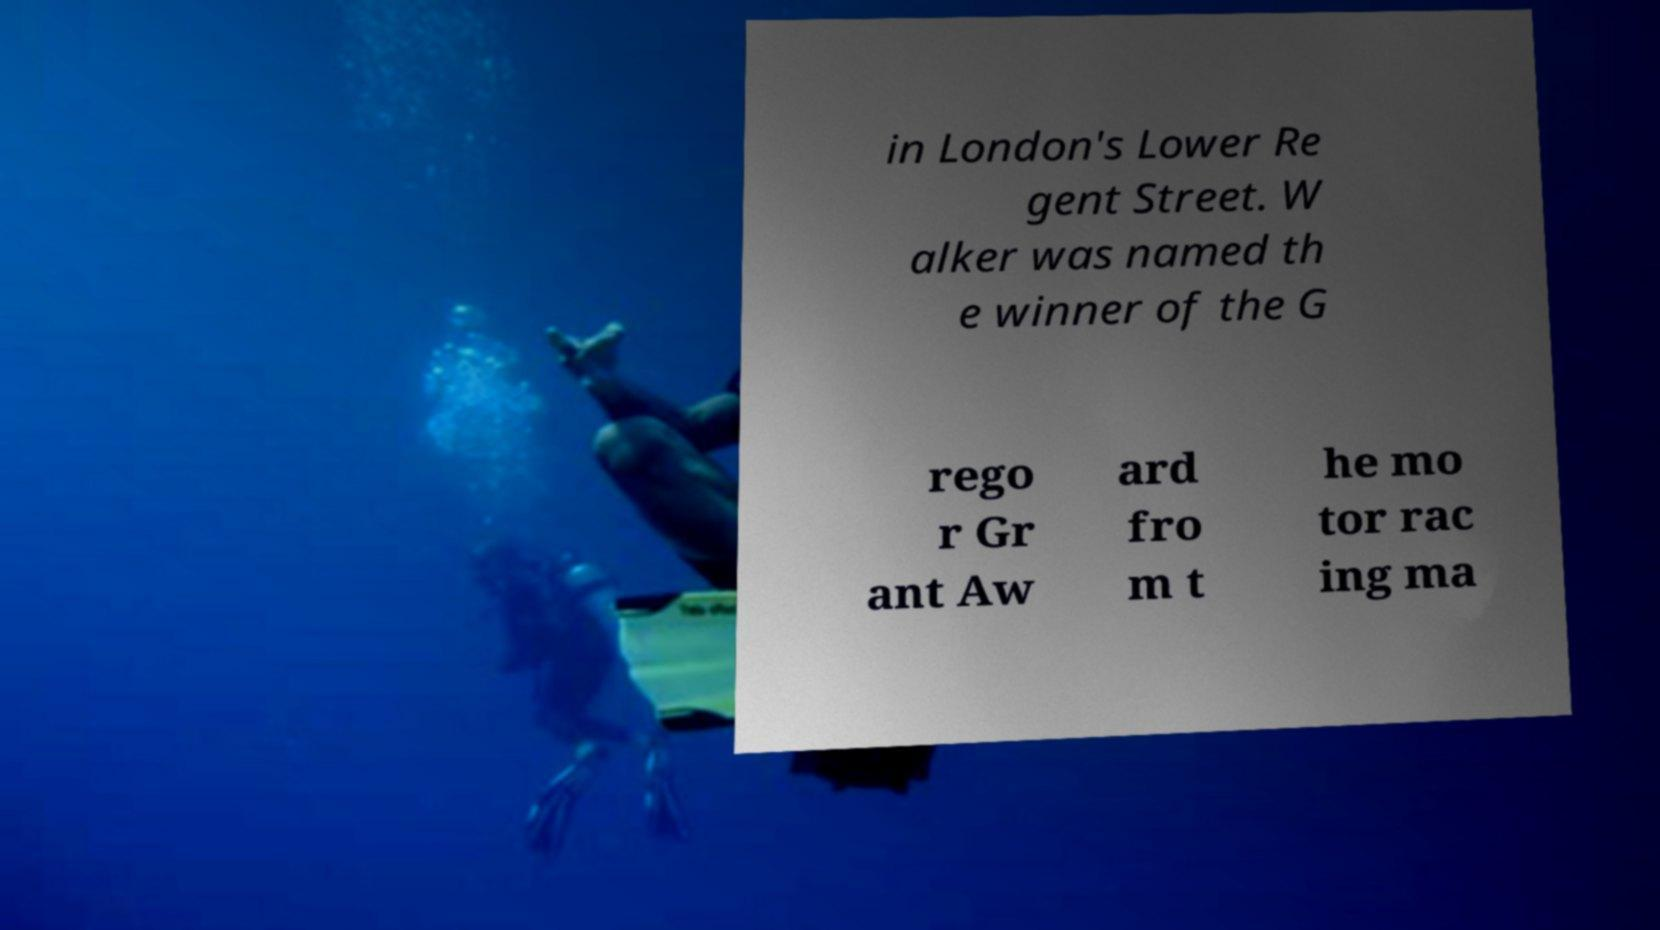For documentation purposes, I need the text within this image transcribed. Could you provide that? in London's Lower Re gent Street. W alker was named th e winner of the G rego r Gr ant Aw ard fro m t he mo tor rac ing ma 